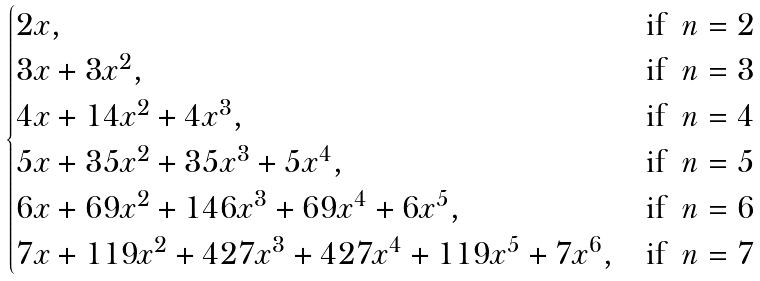Convert formula to latex. <formula><loc_0><loc_0><loc_500><loc_500>\begin{cases} 2 x , & \text {if \ $n = 2$} \\ 3 x + 3 x ^ { 2 } , & \text {if \ $n = 3$} \\ 4 x + 1 4 x ^ { 2 } + 4 x ^ { 3 } , & \text {if \ $n = 4$} \\ 5 x + 3 5 x ^ { 2 } + 3 5 x ^ { 3 } + 5 x ^ { 4 } , & \text {if \ $n = 5$} \\ 6 x + 6 9 x ^ { 2 } + 1 4 6 x ^ { 3 } + 6 9 x ^ { 4 } + 6 x ^ { 5 } , & \text {if \ $n = 6$} \\ 7 x + 1 1 9 x ^ { 2 } + 4 2 7 x ^ { 3 } + 4 2 7 x ^ { 4 } + 1 1 9 x ^ { 5 } + 7 x ^ { 6 } , & \text {if \ $n = 7$} \\ \end{cases}</formula> 